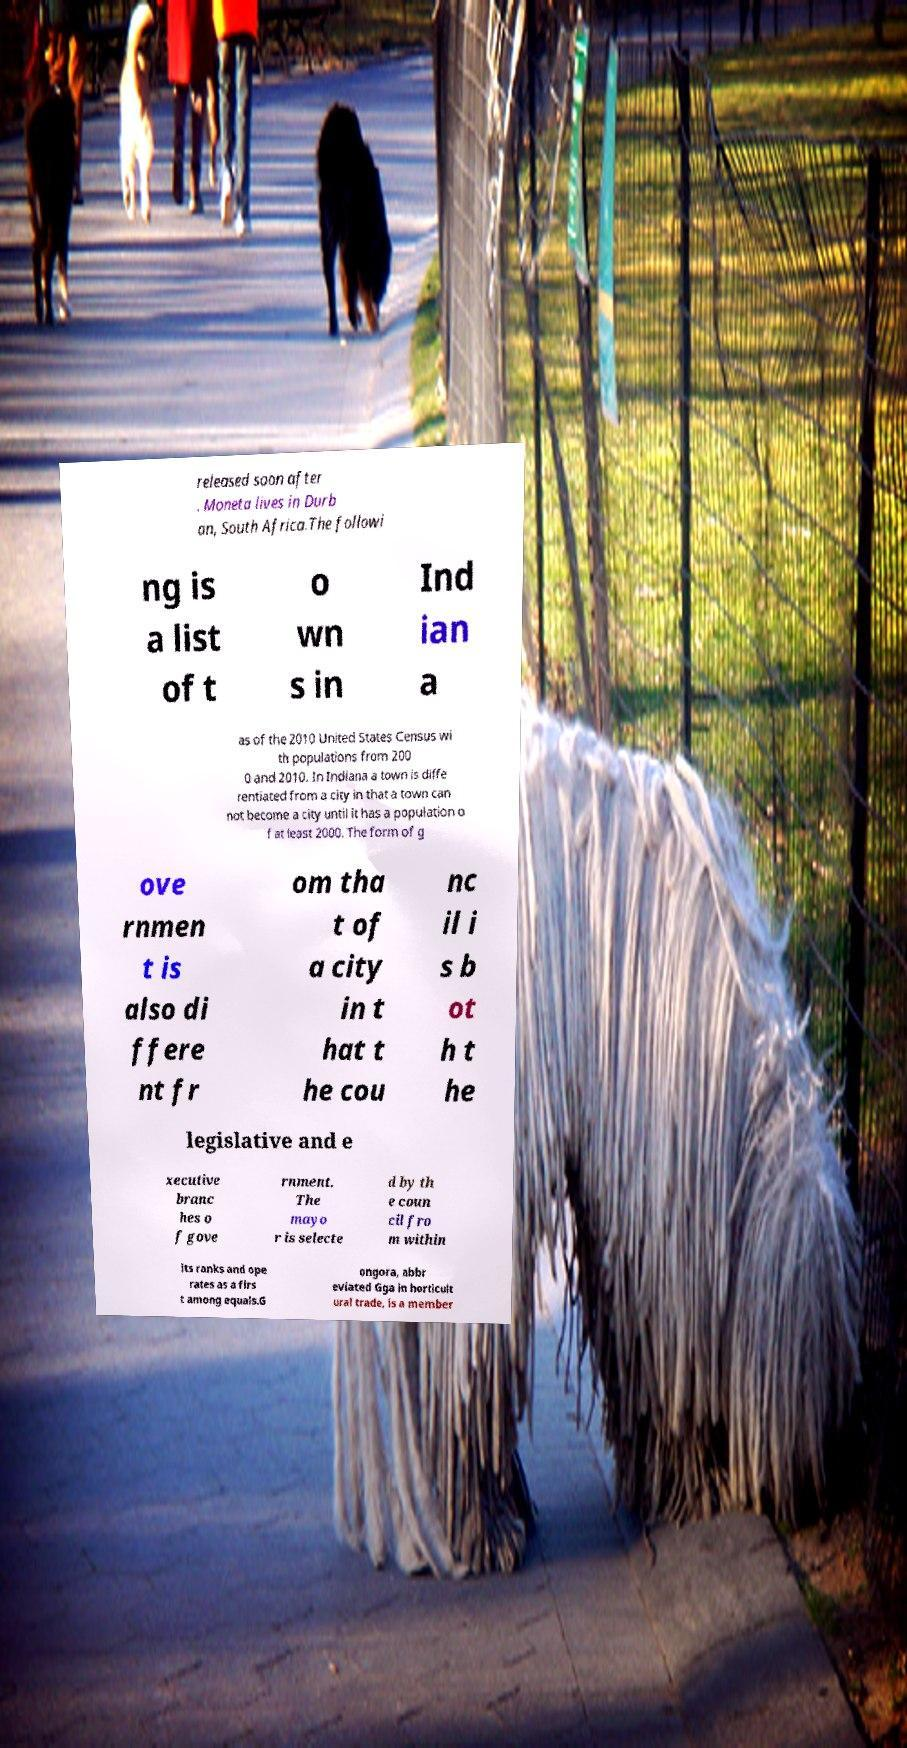Can you accurately transcribe the text from the provided image for me? released soon after . Moneta lives in Durb an, South Africa.The followi ng is a list of t o wn s in Ind ian a as of the 2010 United States Census wi th populations from 200 0 and 2010. In Indiana a town is diffe rentiated from a city in that a town can not become a city until it has a population o f at least 2000. The form of g ove rnmen t is also di ffere nt fr om tha t of a city in t hat t he cou nc il i s b ot h t he legislative and e xecutive branc hes o f gove rnment. The mayo r is selecte d by th e coun cil fro m within its ranks and ope rates as a firs t among equals.G ongora, abbr eviated Gga in horticult ural trade, is a member 